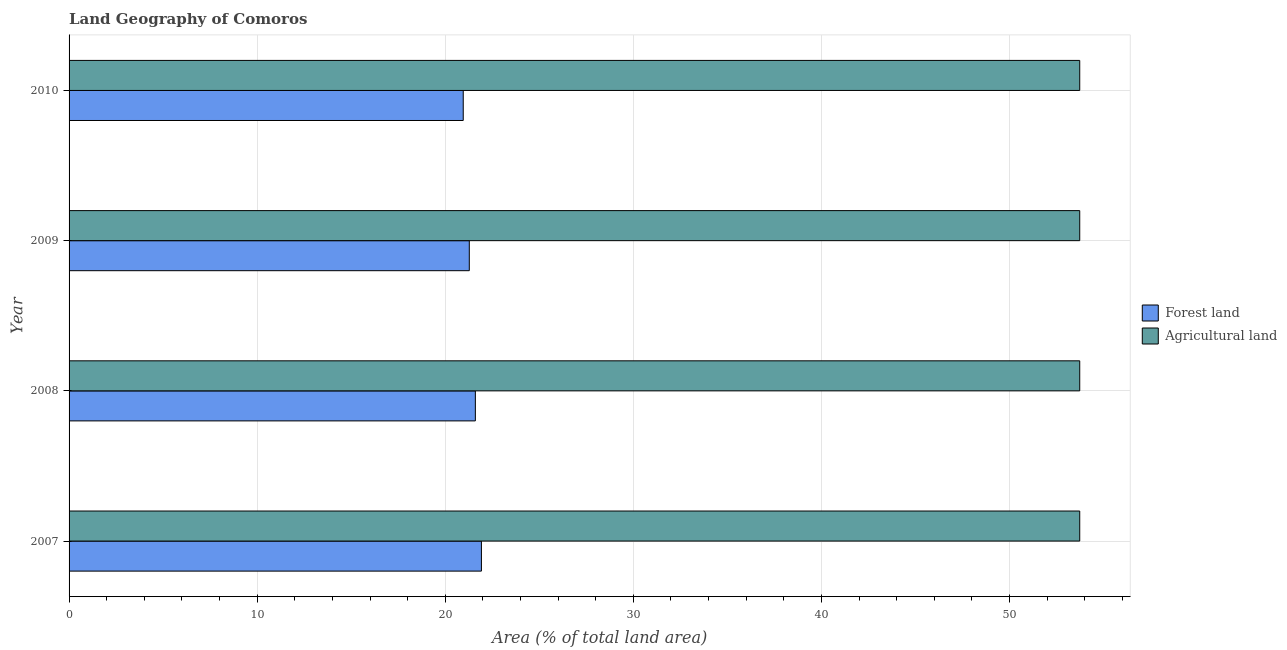How many bars are there on the 1st tick from the top?
Provide a short and direct response. 2. What is the label of the 4th group of bars from the top?
Give a very brief answer. 2007. In how many cases, is the number of bars for a given year not equal to the number of legend labels?
Offer a very short reply. 0. What is the percentage of land area under agriculture in 2008?
Keep it short and to the point. 53.73. Across all years, what is the maximum percentage of land area under agriculture?
Offer a terse response. 53.73. Across all years, what is the minimum percentage of land area under forests?
Keep it short and to the point. 20.96. In which year was the percentage of land area under agriculture maximum?
Offer a terse response. 2007. In which year was the percentage of land area under forests minimum?
Provide a succinct answer. 2010. What is the total percentage of land area under agriculture in the graph?
Keep it short and to the point. 214.94. What is the difference between the percentage of land area under forests in 2007 and that in 2009?
Ensure brevity in your answer.  0.65. What is the difference between the percentage of land area under forests in 2008 and the percentage of land area under agriculture in 2010?
Make the answer very short. -32.13. What is the average percentage of land area under agriculture per year?
Ensure brevity in your answer.  53.73. In the year 2009, what is the difference between the percentage of land area under forests and percentage of land area under agriculture?
Offer a very short reply. -32.46. In how many years, is the percentage of land area under forests greater than 42 %?
Make the answer very short. 0. What is the difference between the highest and the second highest percentage of land area under forests?
Make the answer very short. 0.32. Is the sum of the percentage of land area under forests in 2008 and 2010 greater than the maximum percentage of land area under agriculture across all years?
Ensure brevity in your answer.  No. What does the 1st bar from the top in 2007 represents?
Offer a terse response. Agricultural land. What does the 1st bar from the bottom in 2007 represents?
Offer a very short reply. Forest land. How many bars are there?
Offer a terse response. 8. What is the difference between two consecutive major ticks on the X-axis?
Provide a succinct answer. 10. Are the values on the major ticks of X-axis written in scientific E-notation?
Your response must be concise. No. Does the graph contain any zero values?
Give a very brief answer. No. Where does the legend appear in the graph?
Give a very brief answer. Center right. How are the legend labels stacked?
Your answer should be compact. Vertical. What is the title of the graph?
Your answer should be compact. Land Geography of Comoros. What is the label or title of the X-axis?
Your response must be concise. Area (% of total land area). What is the Area (% of total land area) of Forest land in 2007?
Your answer should be compact. 21.92. What is the Area (% of total land area) of Agricultural land in 2007?
Offer a terse response. 53.73. What is the Area (% of total land area) in Forest land in 2008?
Offer a very short reply. 21.6. What is the Area (% of total land area) of Agricultural land in 2008?
Provide a short and direct response. 53.73. What is the Area (% of total land area) of Forest land in 2009?
Provide a short and direct response. 21.28. What is the Area (% of total land area) of Agricultural land in 2009?
Ensure brevity in your answer.  53.73. What is the Area (% of total land area) in Forest land in 2010?
Make the answer very short. 20.96. What is the Area (% of total land area) in Agricultural land in 2010?
Make the answer very short. 53.73. Across all years, what is the maximum Area (% of total land area) in Forest land?
Offer a very short reply. 21.92. Across all years, what is the maximum Area (% of total land area) in Agricultural land?
Your answer should be very brief. 53.73. Across all years, what is the minimum Area (% of total land area) of Forest land?
Your response must be concise. 20.96. Across all years, what is the minimum Area (% of total land area) of Agricultural land?
Ensure brevity in your answer.  53.73. What is the total Area (% of total land area) of Forest land in the graph?
Ensure brevity in your answer.  85.76. What is the total Area (% of total land area) in Agricultural land in the graph?
Offer a very short reply. 214.94. What is the difference between the Area (% of total land area) in Forest land in 2007 and that in 2008?
Your answer should be compact. 0.32. What is the difference between the Area (% of total land area) in Forest land in 2007 and that in 2009?
Keep it short and to the point. 0.64. What is the difference between the Area (% of total land area) in Forest land in 2007 and that in 2010?
Ensure brevity in your answer.  0.97. What is the difference between the Area (% of total land area) in Forest land in 2008 and that in 2009?
Keep it short and to the point. 0.32. What is the difference between the Area (% of total land area) in Forest land in 2008 and that in 2010?
Your answer should be compact. 0.64. What is the difference between the Area (% of total land area) in Forest land in 2009 and that in 2010?
Give a very brief answer. 0.32. What is the difference between the Area (% of total land area) of Forest land in 2007 and the Area (% of total land area) of Agricultural land in 2008?
Provide a short and direct response. -31.81. What is the difference between the Area (% of total land area) of Forest land in 2007 and the Area (% of total land area) of Agricultural land in 2009?
Your answer should be very brief. -31.81. What is the difference between the Area (% of total land area) of Forest land in 2007 and the Area (% of total land area) of Agricultural land in 2010?
Your answer should be compact. -31.81. What is the difference between the Area (% of total land area) of Forest land in 2008 and the Area (% of total land area) of Agricultural land in 2009?
Your answer should be compact. -32.13. What is the difference between the Area (% of total land area) in Forest land in 2008 and the Area (% of total land area) in Agricultural land in 2010?
Give a very brief answer. -32.13. What is the difference between the Area (% of total land area) of Forest land in 2009 and the Area (% of total land area) of Agricultural land in 2010?
Your answer should be very brief. -32.46. What is the average Area (% of total land area) in Forest land per year?
Your answer should be compact. 21.44. What is the average Area (% of total land area) of Agricultural land per year?
Make the answer very short. 53.73. In the year 2007, what is the difference between the Area (% of total land area) of Forest land and Area (% of total land area) of Agricultural land?
Provide a short and direct response. -31.81. In the year 2008, what is the difference between the Area (% of total land area) of Forest land and Area (% of total land area) of Agricultural land?
Provide a short and direct response. -32.13. In the year 2009, what is the difference between the Area (% of total land area) in Forest land and Area (% of total land area) in Agricultural land?
Offer a terse response. -32.46. In the year 2010, what is the difference between the Area (% of total land area) in Forest land and Area (% of total land area) in Agricultural land?
Offer a very short reply. -32.78. What is the ratio of the Area (% of total land area) of Forest land in 2007 to that in 2008?
Your response must be concise. 1.01. What is the ratio of the Area (% of total land area) in Agricultural land in 2007 to that in 2008?
Keep it short and to the point. 1. What is the ratio of the Area (% of total land area) in Forest land in 2007 to that in 2009?
Give a very brief answer. 1.03. What is the ratio of the Area (% of total land area) in Forest land in 2007 to that in 2010?
Your answer should be compact. 1.05. What is the ratio of the Area (% of total land area) of Forest land in 2008 to that in 2009?
Offer a very short reply. 1.02. What is the ratio of the Area (% of total land area) of Forest land in 2008 to that in 2010?
Your answer should be very brief. 1.03. What is the ratio of the Area (% of total land area) of Forest land in 2009 to that in 2010?
Offer a terse response. 1.02. What is the difference between the highest and the second highest Area (% of total land area) in Forest land?
Offer a very short reply. 0.32. What is the difference between the highest and the second highest Area (% of total land area) of Agricultural land?
Give a very brief answer. 0. What is the difference between the highest and the lowest Area (% of total land area) of Forest land?
Provide a short and direct response. 0.97. 